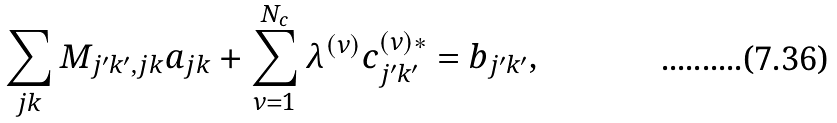Convert formula to latex. <formula><loc_0><loc_0><loc_500><loc_500>\sum _ { j k } M _ { j ^ { \prime } k ^ { \prime } , j k } a _ { j k } + \sum _ { \nu = 1 } ^ { N _ { c } } \lambda ^ { ( \nu ) } c ^ { ( \nu ) * } _ { j ^ { \prime } k ^ { \prime } } = b _ { j ^ { \prime } k ^ { \prime } } ,</formula> 